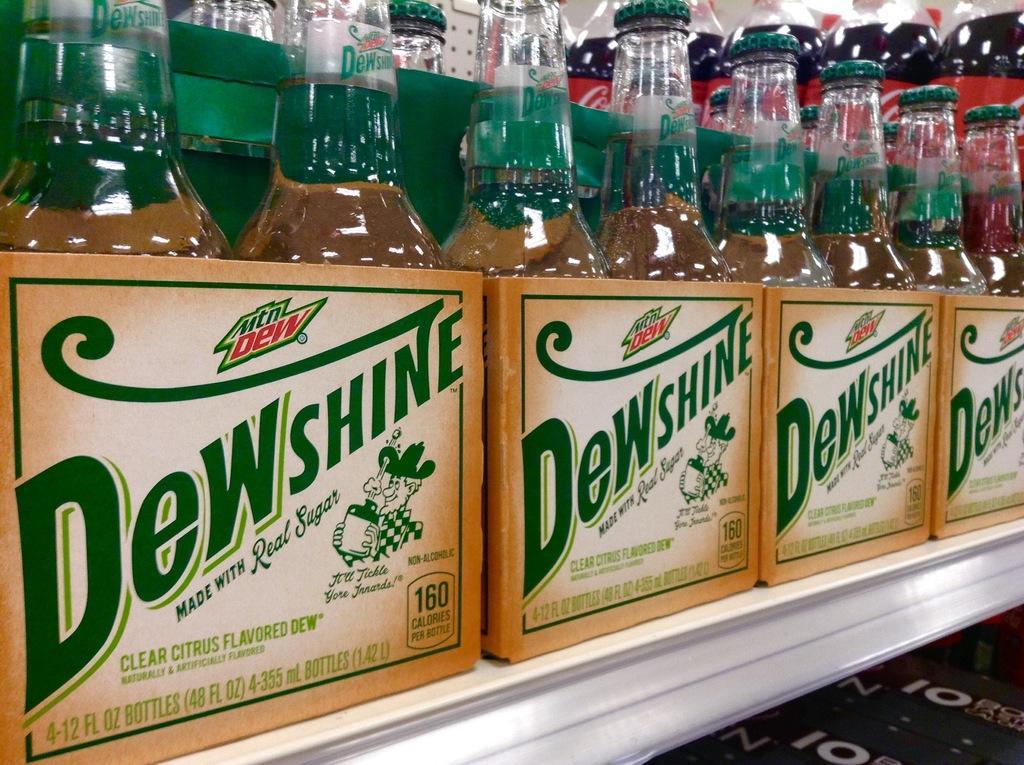In one or two sentences, can you explain what this image depicts? on a white table there are boxes of glass bottles. on the boxes dewshine is written. behind them there are other plastic bottles. 